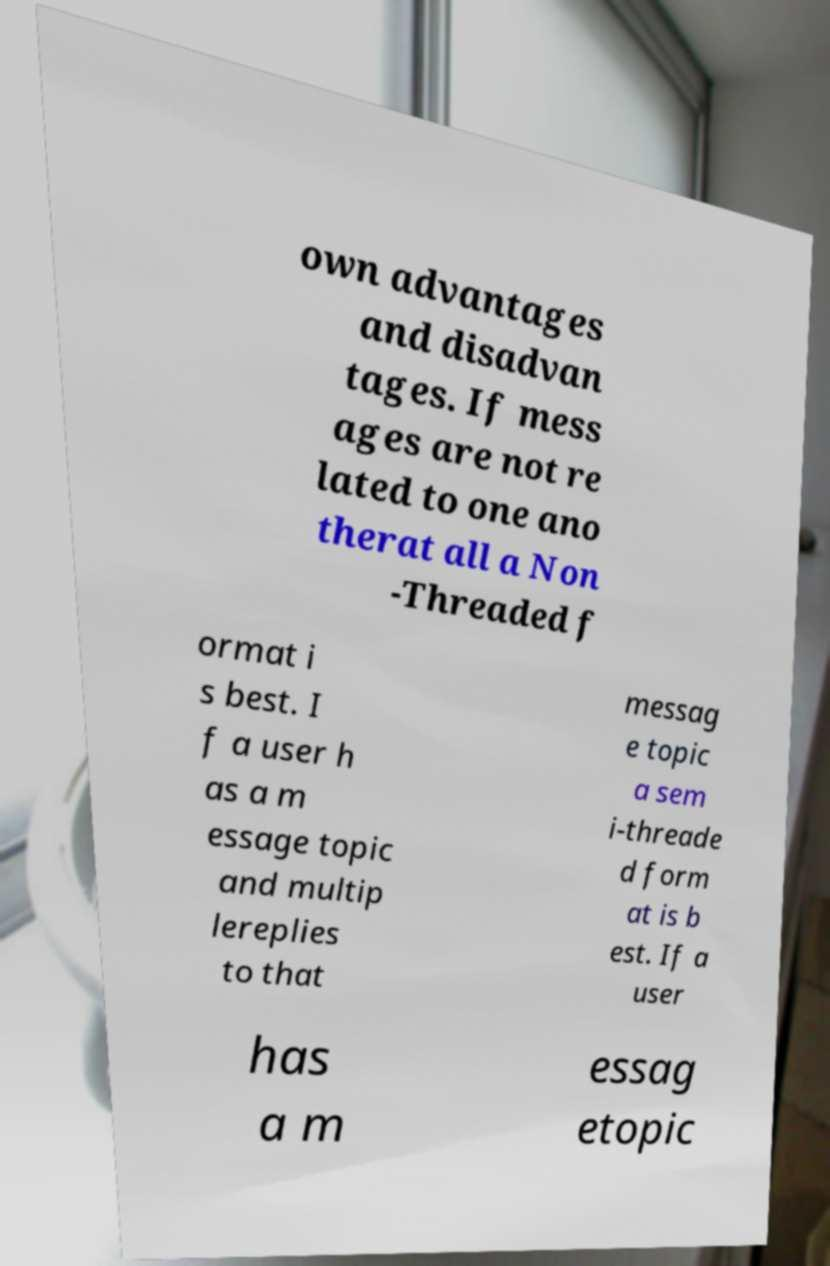Can you accurately transcribe the text from the provided image for me? own advantages and disadvan tages. If mess ages are not re lated to one ano therat all a Non -Threaded f ormat i s best. I f a user h as a m essage topic and multip lereplies to that messag e topic a sem i-threade d form at is b est. If a user has a m essag etopic 